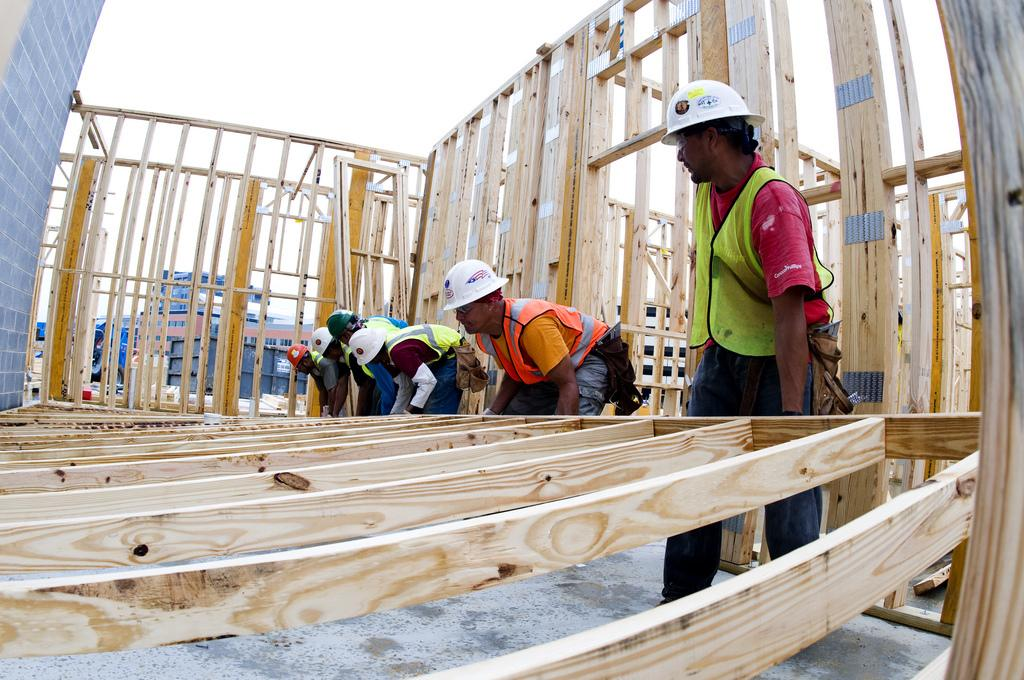What is being built in the image? There is a shed under construction in the image. Who are the people in the image? There are men wearing jackets in the image. What are the men wearing on their heads? The men are wearing caps on their heads. What are the men doing in the image? The men are lifting a wooden object. What is visible at the top of the image? The sky is visible at the top of the image. What type of table is being used by the actor in the image? There is no table or actor present in the image; it features a shed under construction and men working on it. What type of roof is being installed on the shed in the image? The image does not show the roof being installed on the shed, only the men lifting a wooden object. 